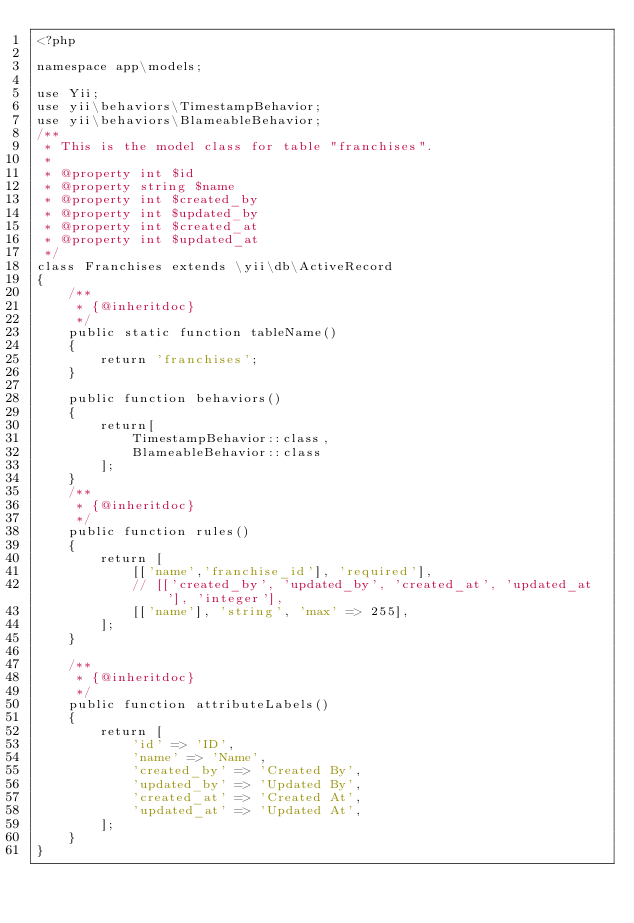Convert code to text. <code><loc_0><loc_0><loc_500><loc_500><_PHP_><?php

namespace app\models;

use Yii;
use yii\behaviors\TimestampBehavior;
use yii\behaviors\BlameableBehavior;
/**
 * This is the model class for table "franchises".
 *
 * @property int $id
 * @property string $name
 * @property int $created_by
 * @property int $updated_by
 * @property int $created_at
 * @property int $updated_at
 */
class Franchises extends \yii\db\ActiveRecord
{
    /**
     * {@inheritdoc}
     */
    public static function tableName()
    {
        return 'franchises';
    }

    public function behaviors()
    {
        return[
            TimestampBehavior::class,
            BlameableBehavior::class
        ];
    }
    /**
     * {@inheritdoc}
     */
    public function rules()
    {
        return [
            [['name','franchise_id'], 'required'],
            // [['created_by', 'updated_by', 'created_at', 'updated_at'], 'integer'],
            [['name'], 'string', 'max' => 255],
        ];
    }

    /**
     * {@inheritdoc}
     */
    public function attributeLabels()
    {
        return [
            'id' => 'ID',
            'name' => 'Name',
            'created_by' => 'Created By',
            'updated_by' => 'Updated By',
            'created_at' => 'Created At',
            'updated_at' => 'Updated At',
        ];
    }
}
</code> 